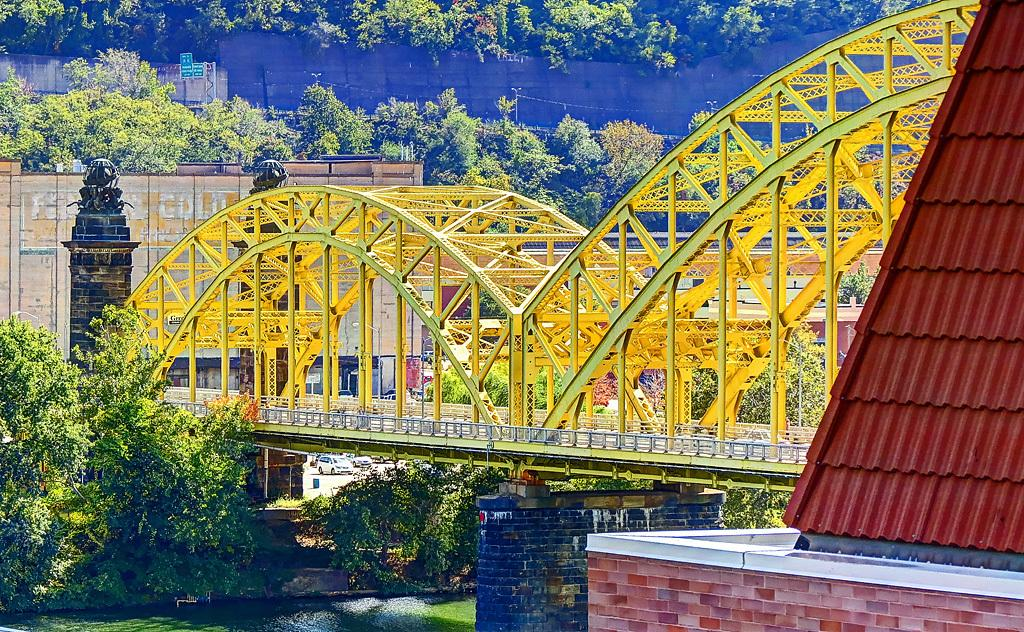What type of structure can be seen in the image? There is a bridge in the image. What else can be seen in the image besides the bridge? There are buildings, vehicles on the road, trees, and boards in the background of the image. Can you describe the road in the image? The road is located under the bridge, and vehicles are visible on it. What other objects can be seen in the background of the image? There are other objects visible in the background, but their specific details are not mentioned in the provided facts. What type of ship can be seen sailing under the bridge in the image? There is no ship visible in the image; it only shows a bridge, buildings, vehicles, trees, and boards in the background. Can you tell me the name of the minister who is standing on the bridge in the image? There is no minister present in the image; it only shows a bridge, buildings, vehicles, trees, and boards in the background. 